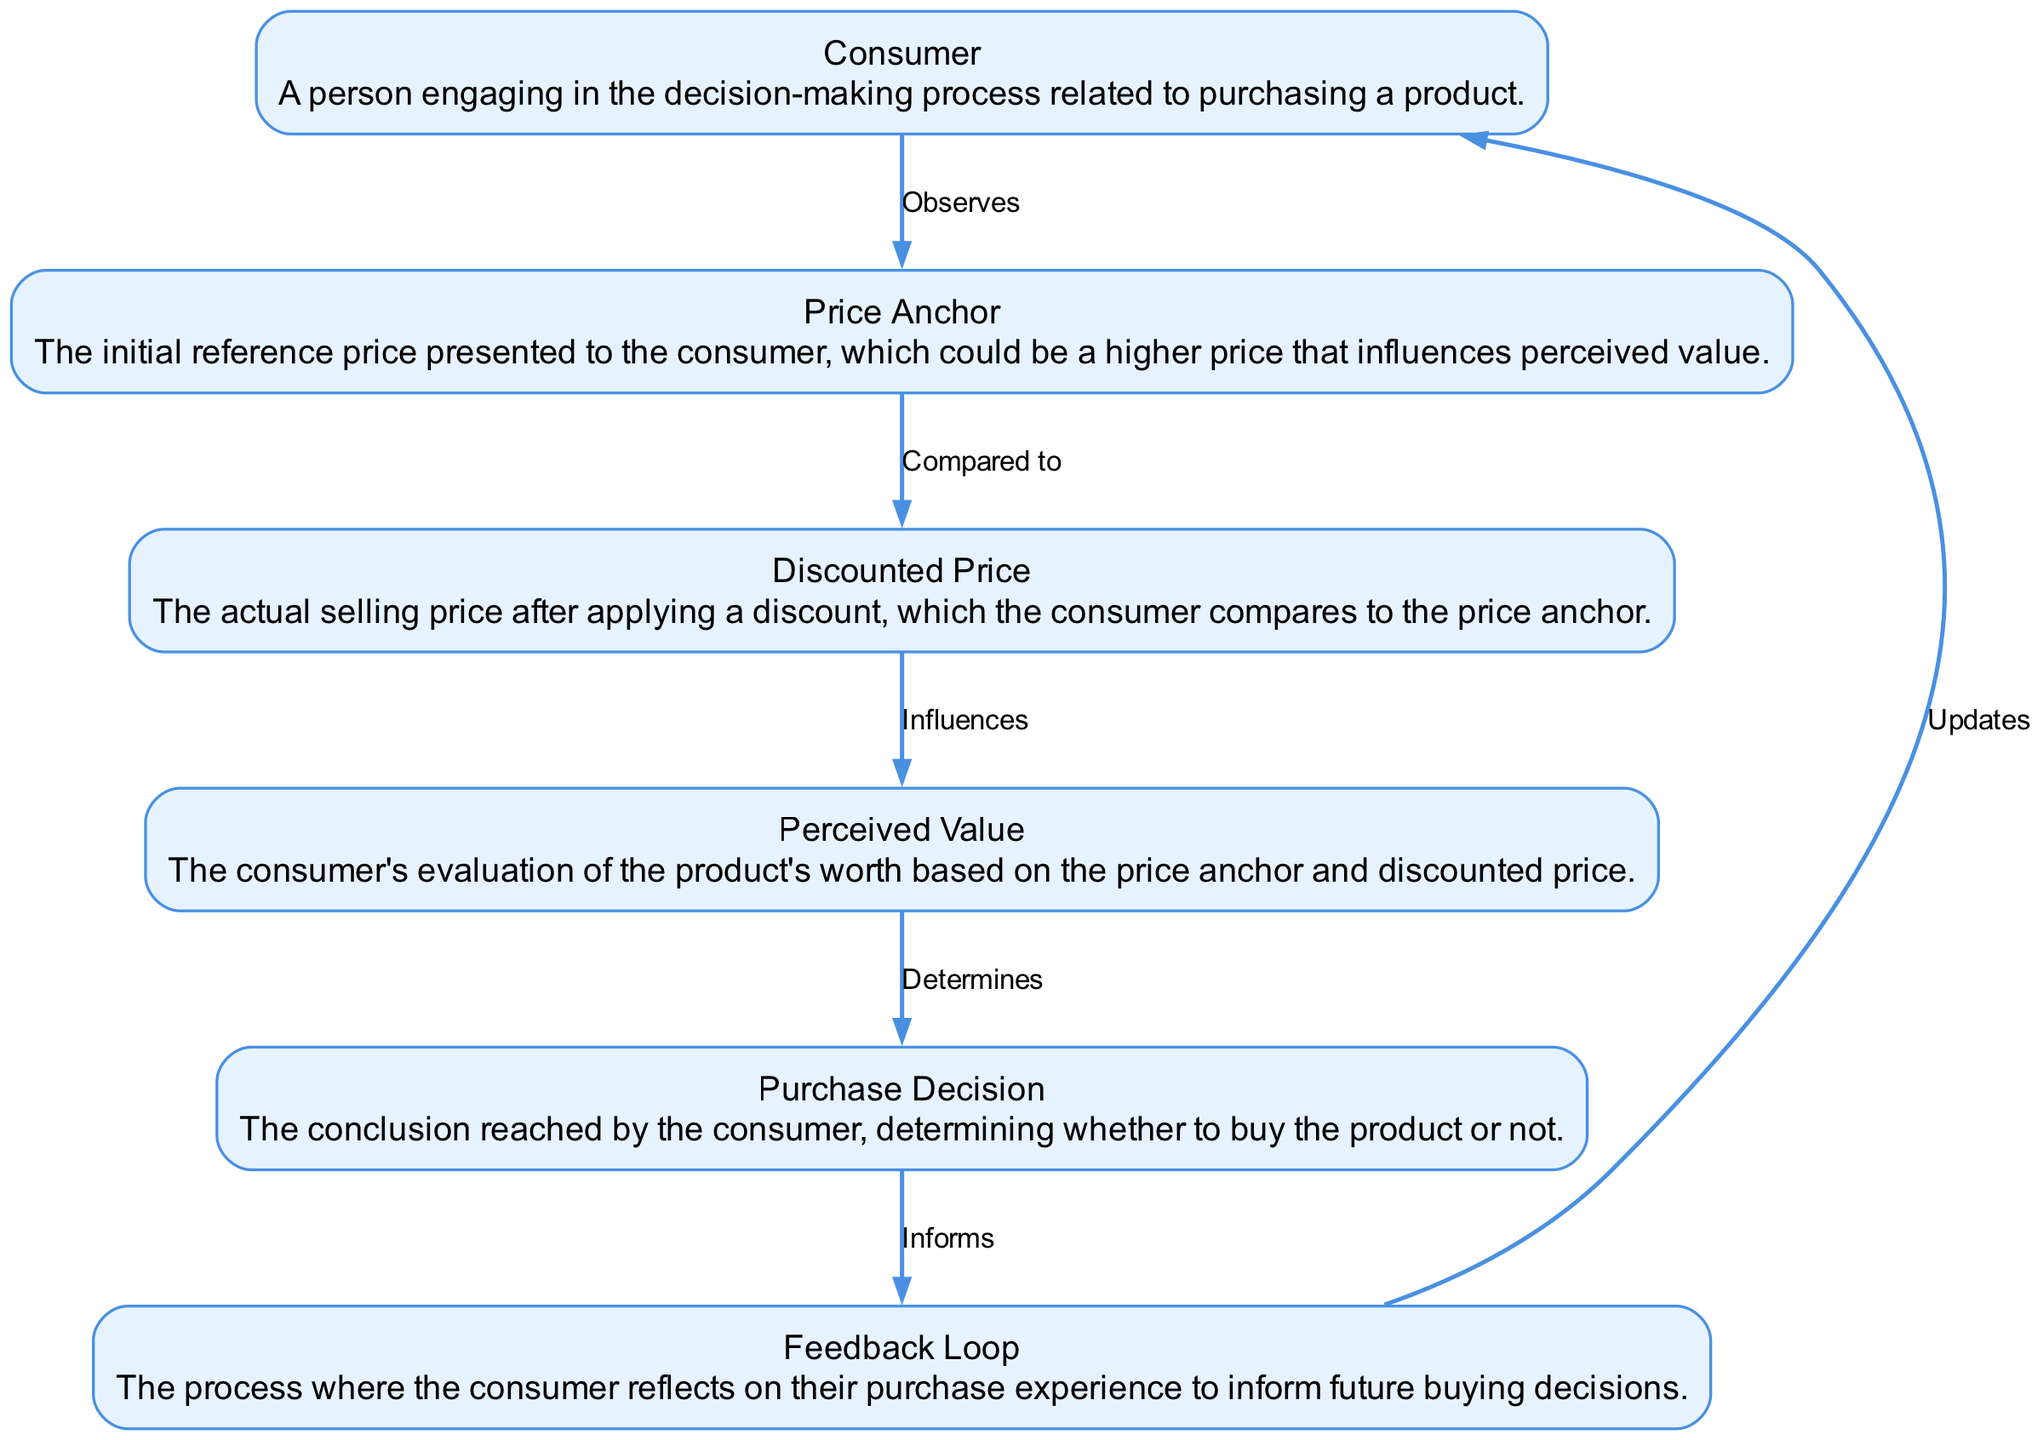What is the first node that the Consumer interacts with? The diagram shows the flow of the consumer decision-making process starting from the Consumer, who first interacts with the Price Anchor.
Answer: Price Anchor How many edges are in the diagram? By counting the connections between the nodes, there are a total of five edges that represent the interactions between the different elements in the diagram.
Answer: Five What does the Price Anchor influence? The diagram indicates that the Price Anchor influences the next node, which is the Discounted Price, as indicated by the labeled edge in the diagram.
Answer: Discounted Price Which node does the Feedback Loop connect back to? The Feedback Loop, as depicted in the diagram, connects back to the Consumer, indicating that it informs the consumer's future decisions based on their experiences.
Answer: Consumer What is the relationship between Perceived Value and Purchase Decision? The diagram illustrates that the Perceived Value directly determines the Purchase Decision, showing a cause-effect relationship between these two nodes.
Answer: Determines How many nodes are involved in the decision-making process? By examining the diagram, I count a total of six distinct nodes that represent different stages in the consumer decision-making process, starting from the Consumer and ending at the Feedback Loop.
Answer: Six What is the last node in the sequence before it loops back? In the diagram, the last node before the loop back to the Consumer is the Feedback Loop, representing the consumer's reflection on their purchase.
Answer: Feedback Loop What kind of decisions does the Feedback Loop inform? The Feedback Loop plays a role in informing future buying decisions based on the consumer's reflection on their purchase experience.
Answer: Future buying decisions What does the Discounted Price compare to? According to the edges depicted in the diagram, the Discounted Price is compared to the Price Anchor, showcasing the consumer's evaluation process.
Answer: Price Anchor 